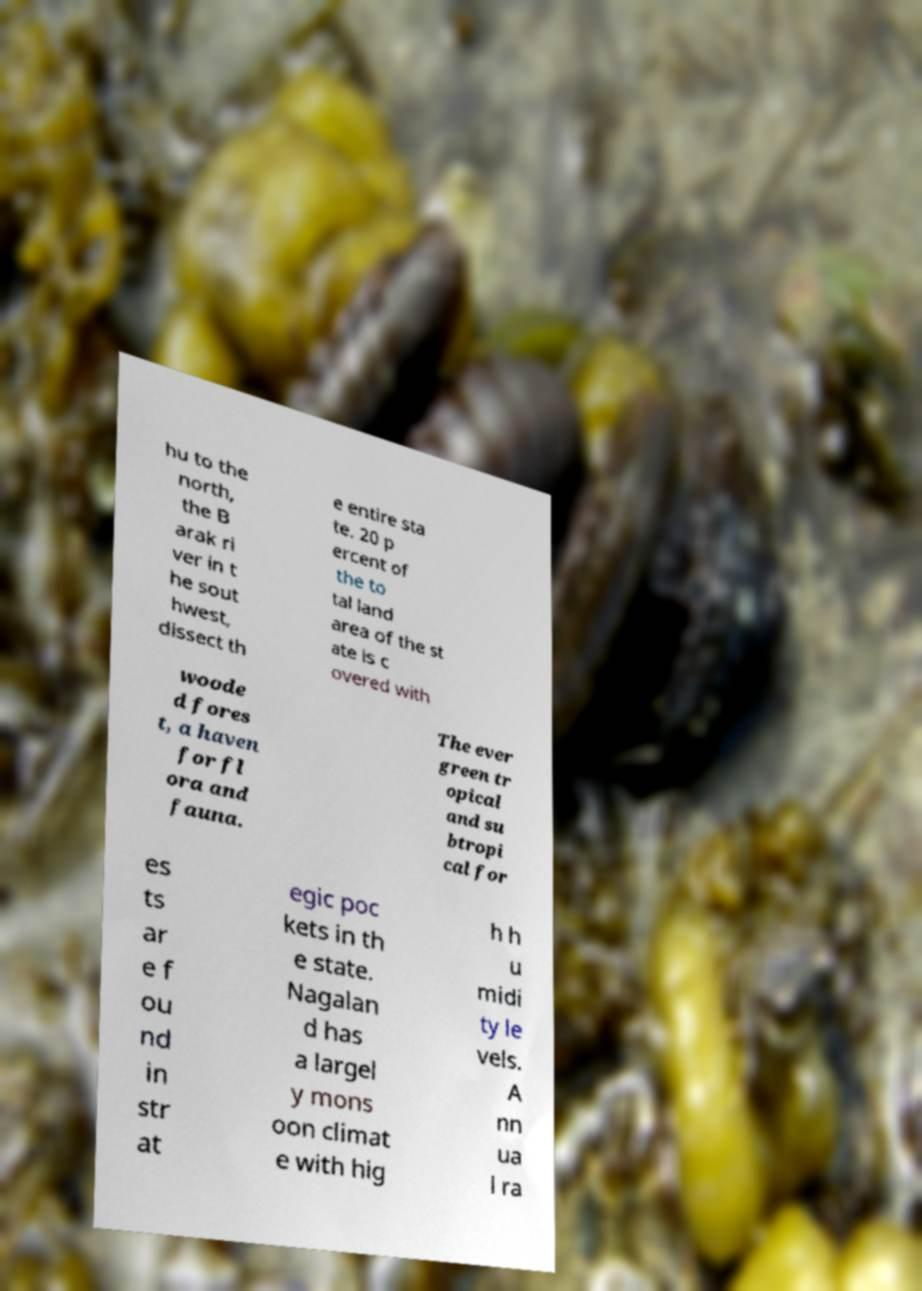What messages or text are displayed in this image? I need them in a readable, typed format. hu to the north, the B arak ri ver in t he sout hwest, dissect th e entire sta te. 20 p ercent of the to tal land area of the st ate is c overed with woode d fores t, a haven for fl ora and fauna. The ever green tr opical and su btropi cal for es ts ar e f ou nd in str at egic poc kets in th e state. Nagalan d has a largel y mons oon climat e with hig h h u midi ty le vels. A nn ua l ra 